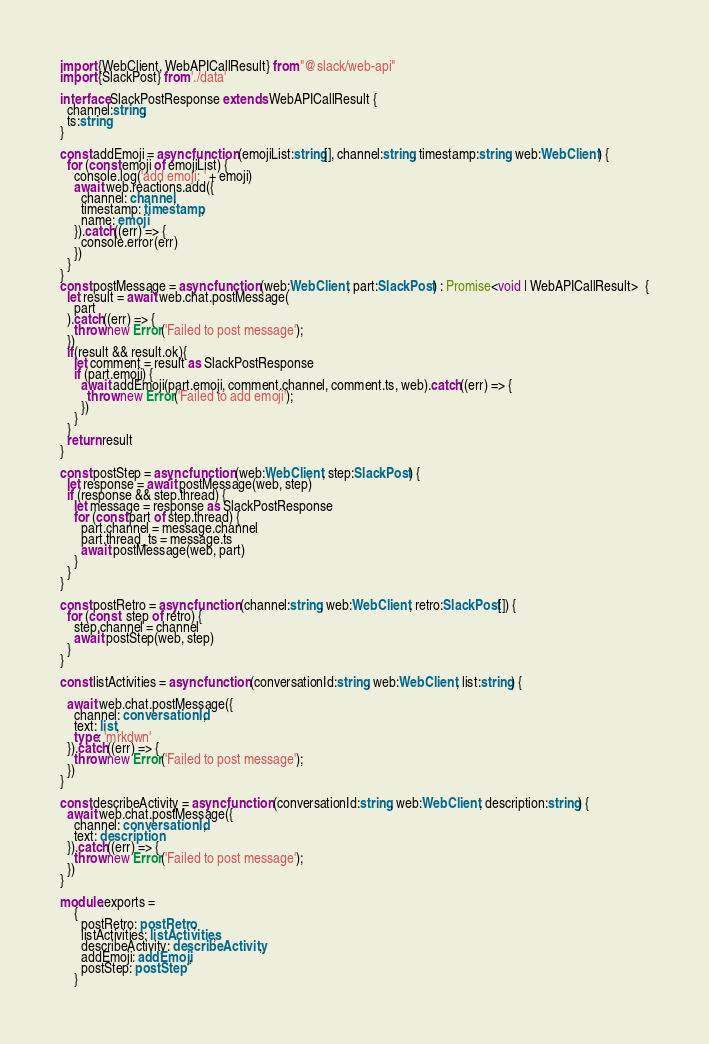<code> <loc_0><loc_0><loc_500><loc_500><_TypeScript_>import {WebClient, WebAPICallResult} from "@slack/web-api"
import {SlackPost} from './data'

interface SlackPostResponse extends WebAPICallResult {
  channel:string,
  ts:string
}

const addEmoji = async function (emojiList:string[], channel:string, timestamp:string, web:WebClient) {
  for (const emoji of emojiList) {
    console.log('add emoji: ' + emoji)
    await web.reactions.add({
      channel: channel,
      timestamp: timestamp,
      name: emoji
    }).catch((err) => {
      console.error(err)
    })
  }
}
const postMessage = async function (web:WebClient, part:SlackPost) : Promise<void | WebAPICallResult>  {
  let result = await web.chat.postMessage(
    part
  ).catch((err) => {
    throw new Error('Failed to post message');
  })
  if(result && result.ok){
    let comment = result as SlackPostResponse
    if (part.emoji) {
      await addEmoji(part.emoji, comment.channel, comment.ts, web).catch((err) => {
        throw new Error('Failed to add emoji');
      })
    }
  }
  return result
}

const postStep = async function (web:WebClient, step:SlackPost) {
  let response = await postMessage(web, step)
  if (response && step.thread) {
    let message = response as SlackPostResponse
    for (const part of step.thread) {
      part.channel = message.channel
      part.thread_ts = message.ts
      await postMessage(web, part)
    }
  }
}

const postRetro = async function (channel:string, web:WebClient, retro:SlackPost[]) {
  for (const  step of retro) {
    step.channel = channel
    await postStep(web, step)
  }
}

const listActivities = async function (conversationId:string, web:WebClient, list:string) {

  await web.chat.postMessage({
    channel: conversationId,
    text: list,
    type: 'mrkdwn'
  }).catch((err) => {
    throw new Error('Failed to post message');
  })
}

const describeActivity = async function (conversationId:string, web:WebClient, description:string) {
  await web.chat.postMessage({
    channel: conversationId,
    text: description
  }).catch((err) => {
    throw new Error('Failed to post message');
  })
}

module.exports =
    {
      postRetro: postRetro,
      listActivities: listActivities,
      describeActivity: describeActivity,
      addEmoji: addEmoji,
      postStep: postStep
    }
</code> 